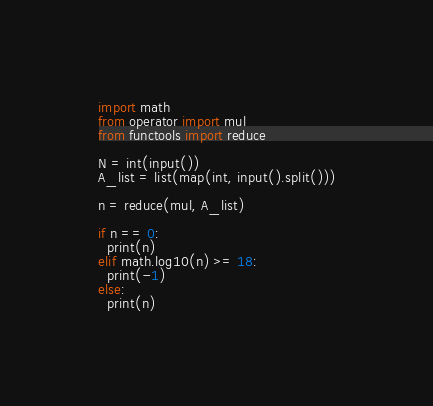Convert code to text. <code><loc_0><loc_0><loc_500><loc_500><_Python_>import math
from operator import mul
from functools import reduce

N = int(input())
A_list = list(map(int, input().split()))

n = reduce(mul, A_list)

if n == 0:
  print(n)
elif math.log10(n) >= 18:
  print(-1)
else:
  print(n)</code> 